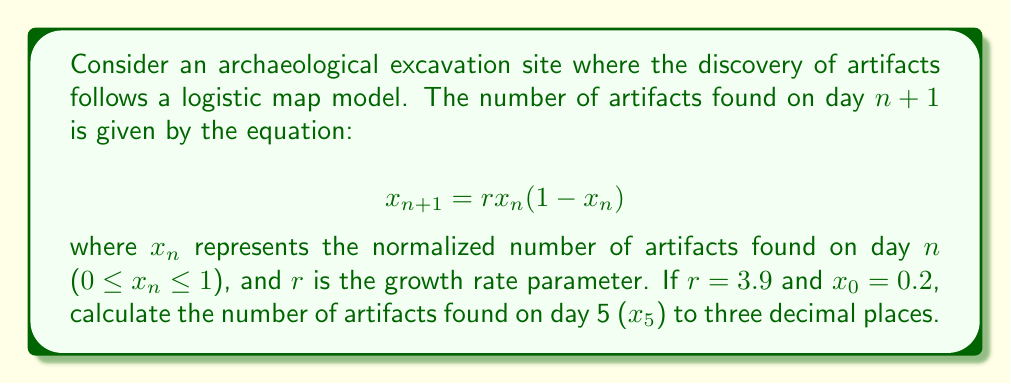Provide a solution to this math problem. To solve this problem, we need to iterate the logistic map equation for 5 days:

1. Day 0: $x_0 = 0.2$ (given)

2. Day 1: $x_1 = r x_0 (1 - x_0)$
   $x_1 = 3.9 \cdot 0.2 \cdot (1 - 0.2) = 3.9 \cdot 0.2 \cdot 0.8 = 0.624$

3. Day 2: $x_2 = r x_1 (1 - x_1)$
   $x_2 = 3.9 \cdot 0.624 \cdot (1 - 0.624) = 3.9 \cdot 0.624 \cdot 0.376 = 0.916$

4. Day 3: $x_3 = r x_2 (1 - x_2)$
   $x_3 = 3.9 \cdot 0.916 \cdot (1 - 0.916) = 3.9 \cdot 0.916 \cdot 0.084 = 0.300$

5. Day 4: $x_4 = r x_3 (1 - x_3)$
   $x_4 = 3.9 \cdot 0.300 \cdot (1 - 0.300) = 3.9 \cdot 0.300 \cdot 0.700 = 0.819$

6. Day 5: $x_5 = r x_4 (1 - x_4)$
   $x_5 = 3.9 \cdot 0.819 \cdot (1 - 0.819) = 3.9 \cdot 0.819 \cdot 0.181 = 0.578$

Rounding to three decimal places, we get $x_5 = 0.578$.
Answer: 0.578 